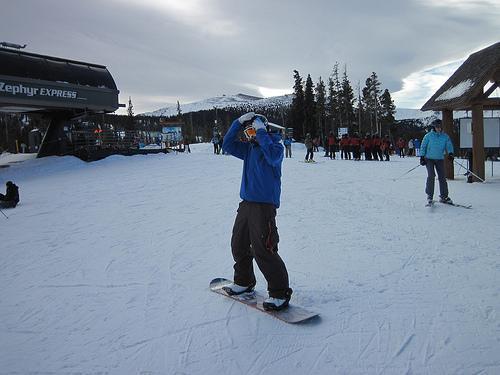How many snowboarders are seen?
Give a very brief answer. 1. 